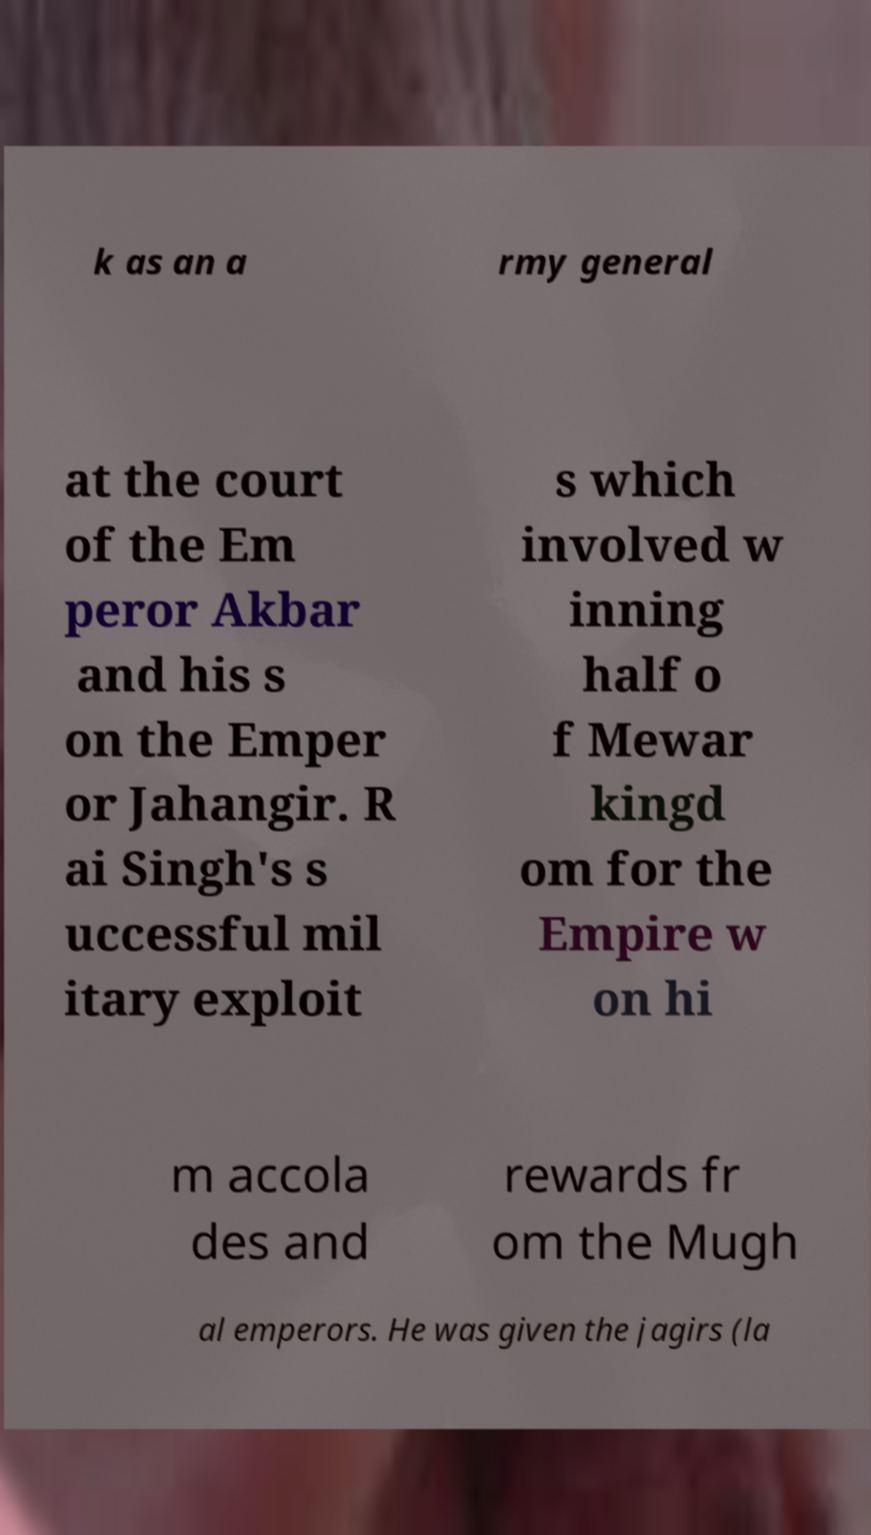There's text embedded in this image that I need extracted. Can you transcribe it verbatim? k as an a rmy general at the court of the Em peror Akbar and his s on the Emper or Jahangir. R ai Singh's s uccessful mil itary exploit s which involved w inning half o f Mewar kingd om for the Empire w on hi m accola des and rewards fr om the Mugh al emperors. He was given the jagirs (la 